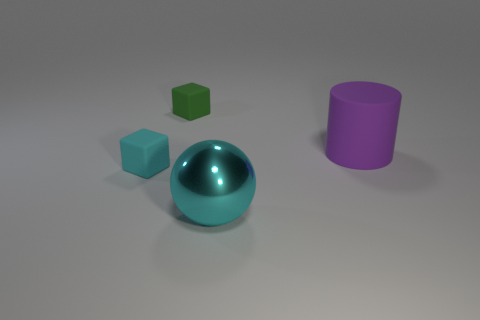Subtract all red cylinders. Subtract all gray balls. How many cylinders are left? 1 Add 1 spheres. How many objects exist? 5 Subtract all cylinders. How many objects are left? 3 Add 4 cyan metal objects. How many cyan metal objects exist? 5 Subtract 0 red cylinders. How many objects are left? 4 Subtract all matte cylinders. Subtract all large matte things. How many objects are left? 2 Add 4 tiny things. How many tiny things are left? 6 